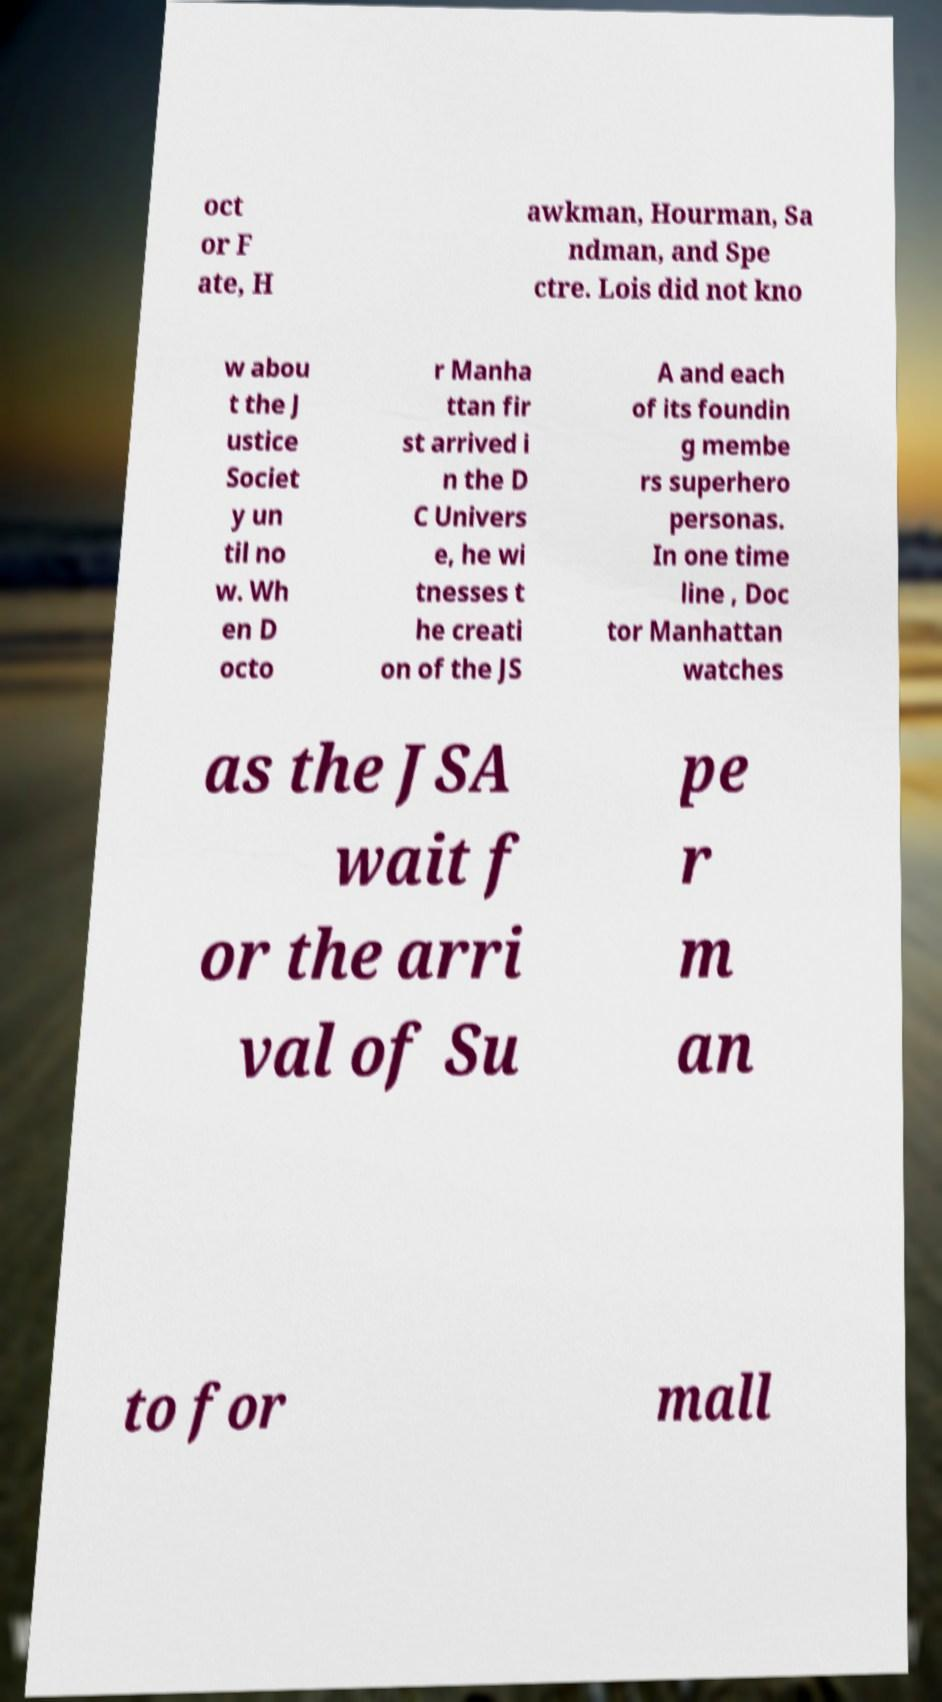For documentation purposes, I need the text within this image transcribed. Could you provide that? oct or F ate, H awkman, Hourman, Sa ndman, and Spe ctre. Lois did not kno w abou t the J ustice Societ y un til no w. Wh en D octo r Manha ttan fir st arrived i n the D C Univers e, he wi tnesses t he creati on of the JS A and each of its foundin g membe rs superhero personas. In one time line , Doc tor Manhattan watches as the JSA wait f or the arri val of Su pe r m an to for mall 